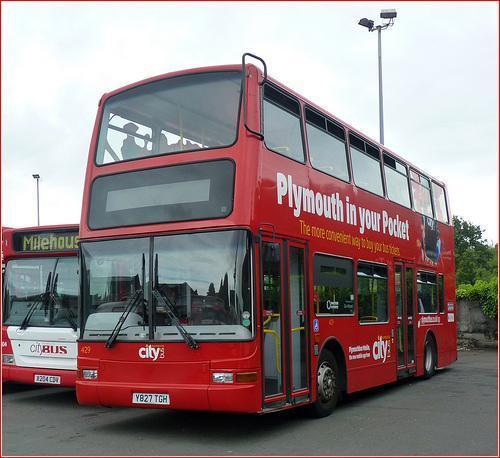How many buses?
Give a very brief answer. 2. 